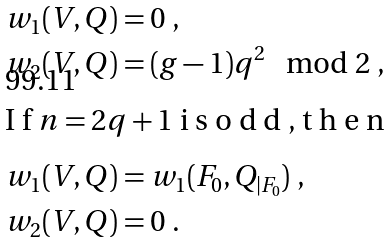<formula> <loc_0><loc_0><loc_500><loc_500>w _ { 1 } ( V , Q ) & = 0 \ , \\ w _ { 2 } ( V , Q ) & = ( g - 1 ) q ^ { 2 } \mod 2 \ , \intertext { I f $ n = 2 q + 1 $ i s o d d , t h e n } w _ { 1 } ( V , Q ) & = w _ { 1 } ( F _ { 0 } , Q _ { | F _ { 0 } } ) \ , \\ w _ { 2 } ( V , Q ) & = 0 \ .</formula> 